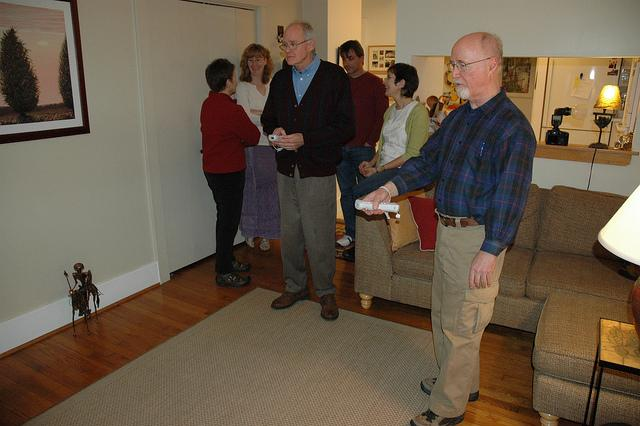Where have these people gathered?

Choices:
A) library
B) home
C) reception hall
D) church home 